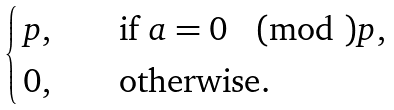Convert formula to latex. <formula><loc_0><loc_0><loc_500><loc_500>\begin{cases} \, p , & \quad \text {if $a = 0 \pmod{ }p$} , \\ \, 0 , & \quad \text {otherwise} . \end{cases}</formula> 